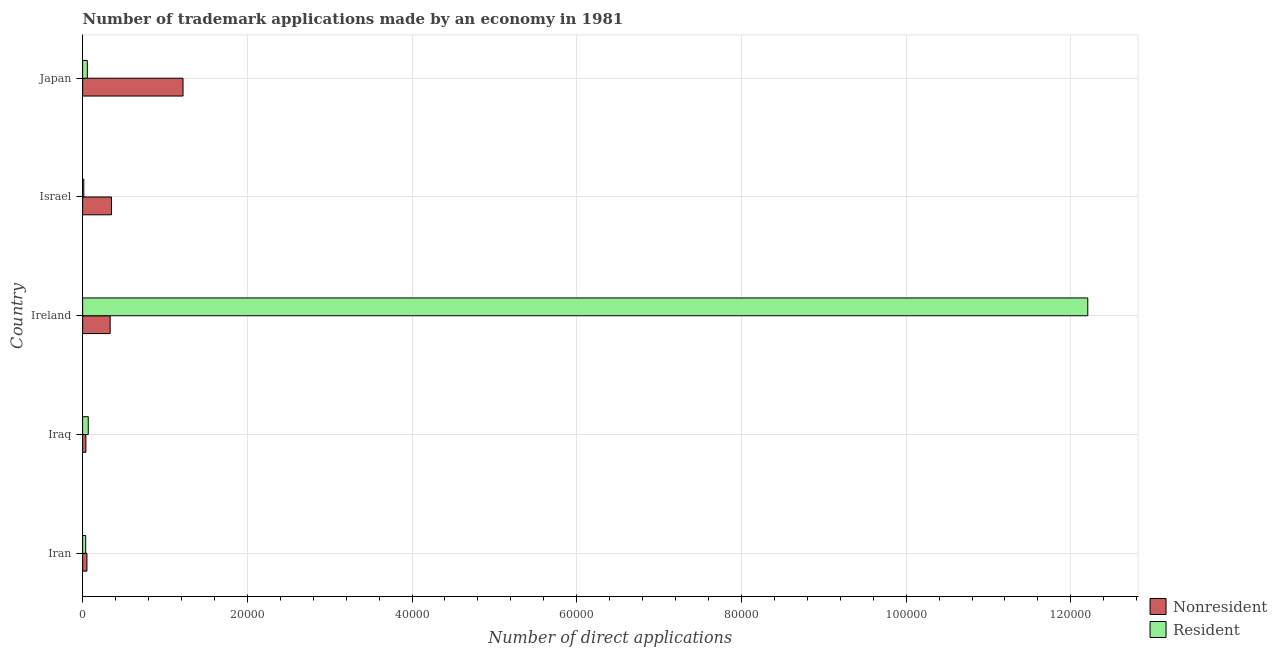What is the number of trademark applications made by residents in Japan?
Your answer should be compact. 570. Across all countries, what is the maximum number of trademark applications made by residents?
Your answer should be very brief. 1.22e+05. Across all countries, what is the minimum number of trademark applications made by residents?
Ensure brevity in your answer.  142. In which country was the number of trademark applications made by residents maximum?
Give a very brief answer. Ireland. In which country was the number of trademark applications made by non residents minimum?
Your answer should be compact. Iraq. What is the total number of trademark applications made by non residents in the graph?
Your answer should be very brief. 2.00e+04. What is the difference between the number of trademark applications made by non residents in Iraq and that in Japan?
Offer a terse response. -1.18e+04. What is the difference between the number of trademark applications made by residents in Japan and the number of trademark applications made by non residents in Israel?
Make the answer very short. -2936. What is the average number of trademark applications made by non residents per country?
Make the answer very short. 3992.2. What is the difference between the number of trademark applications made by residents and number of trademark applications made by non residents in Japan?
Make the answer very short. -1.16e+04. In how many countries, is the number of trademark applications made by residents greater than 8000 ?
Keep it short and to the point. 1. What is the ratio of the number of trademark applications made by non residents in Iran to that in Japan?
Make the answer very short. 0.04. What is the difference between the highest and the second highest number of trademark applications made by non residents?
Keep it short and to the point. 8686. What is the difference between the highest and the lowest number of trademark applications made by non residents?
Keep it short and to the point. 1.18e+04. Is the sum of the number of trademark applications made by non residents in Iran and Iraq greater than the maximum number of trademark applications made by residents across all countries?
Offer a very short reply. No. What does the 1st bar from the top in Iran represents?
Offer a very short reply. Resident. What does the 2nd bar from the bottom in Israel represents?
Your response must be concise. Resident. How many countries are there in the graph?
Your answer should be very brief. 5. Where does the legend appear in the graph?
Provide a succinct answer. Bottom right. How many legend labels are there?
Make the answer very short. 2. How are the legend labels stacked?
Provide a succinct answer. Vertical. What is the title of the graph?
Provide a succinct answer. Number of trademark applications made by an economy in 1981. Does "Merchandise exports" appear as one of the legend labels in the graph?
Offer a terse response. No. What is the label or title of the X-axis?
Your response must be concise. Number of direct applications. What is the label or title of the Y-axis?
Provide a short and direct response. Country. What is the Number of direct applications of Nonresident in Iran?
Your response must be concise. 523. What is the Number of direct applications in Resident in Iran?
Your answer should be compact. 373. What is the Number of direct applications in Nonresident in Iraq?
Your response must be concise. 397. What is the Number of direct applications in Resident in Iraq?
Give a very brief answer. 684. What is the Number of direct applications of Nonresident in Ireland?
Give a very brief answer. 3343. What is the Number of direct applications of Resident in Ireland?
Offer a very short reply. 1.22e+05. What is the Number of direct applications in Nonresident in Israel?
Keep it short and to the point. 3506. What is the Number of direct applications of Resident in Israel?
Keep it short and to the point. 142. What is the Number of direct applications of Nonresident in Japan?
Your answer should be compact. 1.22e+04. What is the Number of direct applications of Resident in Japan?
Offer a terse response. 570. Across all countries, what is the maximum Number of direct applications of Nonresident?
Offer a terse response. 1.22e+04. Across all countries, what is the maximum Number of direct applications in Resident?
Your answer should be very brief. 1.22e+05. Across all countries, what is the minimum Number of direct applications of Nonresident?
Your response must be concise. 397. Across all countries, what is the minimum Number of direct applications in Resident?
Offer a terse response. 142. What is the total Number of direct applications of Nonresident in the graph?
Your response must be concise. 2.00e+04. What is the total Number of direct applications of Resident in the graph?
Offer a very short reply. 1.24e+05. What is the difference between the Number of direct applications in Nonresident in Iran and that in Iraq?
Provide a short and direct response. 126. What is the difference between the Number of direct applications of Resident in Iran and that in Iraq?
Give a very brief answer. -311. What is the difference between the Number of direct applications in Nonresident in Iran and that in Ireland?
Give a very brief answer. -2820. What is the difference between the Number of direct applications of Resident in Iran and that in Ireland?
Give a very brief answer. -1.22e+05. What is the difference between the Number of direct applications in Nonresident in Iran and that in Israel?
Offer a terse response. -2983. What is the difference between the Number of direct applications in Resident in Iran and that in Israel?
Offer a very short reply. 231. What is the difference between the Number of direct applications of Nonresident in Iran and that in Japan?
Your response must be concise. -1.17e+04. What is the difference between the Number of direct applications of Resident in Iran and that in Japan?
Your answer should be compact. -197. What is the difference between the Number of direct applications in Nonresident in Iraq and that in Ireland?
Ensure brevity in your answer.  -2946. What is the difference between the Number of direct applications in Resident in Iraq and that in Ireland?
Your answer should be compact. -1.21e+05. What is the difference between the Number of direct applications of Nonresident in Iraq and that in Israel?
Your response must be concise. -3109. What is the difference between the Number of direct applications of Resident in Iraq and that in Israel?
Your response must be concise. 542. What is the difference between the Number of direct applications in Nonresident in Iraq and that in Japan?
Offer a very short reply. -1.18e+04. What is the difference between the Number of direct applications of Resident in Iraq and that in Japan?
Give a very brief answer. 114. What is the difference between the Number of direct applications of Nonresident in Ireland and that in Israel?
Keep it short and to the point. -163. What is the difference between the Number of direct applications of Resident in Ireland and that in Israel?
Make the answer very short. 1.22e+05. What is the difference between the Number of direct applications in Nonresident in Ireland and that in Japan?
Provide a short and direct response. -8849. What is the difference between the Number of direct applications in Resident in Ireland and that in Japan?
Ensure brevity in your answer.  1.21e+05. What is the difference between the Number of direct applications in Nonresident in Israel and that in Japan?
Your answer should be very brief. -8686. What is the difference between the Number of direct applications in Resident in Israel and that in Japan?
Make the answer very short. -428. What is the difference between the Number of direct applications in Nonresident in Iran and the Number of direct applications in Resident in Iraq?
Ensure brevity in your answer.  -161. What is the difference between the Number of direct applications in Nonresident in Iran and the Number of direct applications in Resident in Ireland?
Provide a short and direct response. -1.22e+05. What is the difference between the Number of direct applications of Nonresident in Iran and the Number of direct applications of Resident in Israel?
Provide a succinct answer. 381. What is the difference between the Number of direct applications of Nonresident in Iran and the Number of direct applications of Resident in Japan?
Make the answer very short. -47. What is the difference between the Number of direct applications of Nonresident in Iraq and the Number of direct applications of Resident in Ireland?
Make the answer very short. -1.22e+05. What is the difference between the Number of direct applications of Nonresident in Iraq and the Number of direct applications of Resident in Israel?
Give a very brief answer. 255. What is the difference between the Number of direct applications of Nonresident in Iraq and the Number of direct applications of Resident in Japan?
Ensure brevity in your answer.  -173. What is the difference between the Number of direct applications in Nonresident in Ireland and the Number of direct applications in Resident in Israel?
Make the answer very short. 3201. What is the difference between the Number of direct applications of Nonresident in Ireland and the Number of direct applications of Resident in Japan?
Provide a succinct answer. 2773. What is the difference between the Number of direct applications of Nonresident in Israel and the Number of direct applications of Resident in Japan?
Keep it short and to the point. 2936. What is the average Number of direct applications in Nonresident per country?
Make the answer very short. 3992.2. What is the average Number of direct applications of Resident per country?
Your answer should be compact. 2.48e+04. What is the difference between the Number of direct applications in Nonresident and Number of direct applications in Resident in Iran?
Provide a succinct answer. 150. What is the difference between the Number of direct applications in Nonresident and Number of direct applications in Resident in Iraq?
Provide a short and direct response. -287. What is the difference between the Number of direct applications of Nonresident and Number of direct applications of Resident in Ireland?
Offer a very short reply. -1.19e+05. What is the difference between the Number of direct applications in Nonresident and Number of direct applications in Resident in Israel?
Your answer should be very brief. 3364. What is the difference between the Number of direct applications of Nonresident and Number of direct applications of Resident in Japan?
Your answer should be compact. 1.16e+04. What is the ratio of the Number of direct applications of Nonresident in Iran to that in Iraq?
Your response must be concise. 1.32. What is the ratio of the Number of direct applications in Resident in Iran to that in Iraq?
Give a very brief answer. 0.55. What is the ratio of the Number of direct applications in Nonresident in Iran to that in Ireland?
Keep it short and to the point. 0.16. What is the ratio of the Number of direct applications in Resident in Iran to that in Ireland?
Make the answer very short. 0. What is the ratio of the Number of direct applications of Nonresident in Iran to that in Israel?
Keep it short and to the point. 0.15. What is the ratio of the Number of direct applications of Resident in Iran to that in Israel?
Give a very brief answer. 2.63. What is the ratio of the Number of direct applications of Nonresident in Iran to that in Japan?
Give a very brief answer. 0.04. What is the ratio of the Number of direct applications of Resident in Iran to that in Japan?
Provide a succinct answer. 0.65. What is the ratio of the Number of direct applications in Nonresident in Iraq to that in Ireland?
Make the answer very short. 0.12. What is the ratio of the Number of direct applications in Resident in Iraq to that in Ireland?
Provide a succinct answer. 0.01. What is the ratio of the Number of direct applications in Nonresident in Iraq to that in Israel?
Your answer should be very brief. 0.11. What is the ratio of the Number of direct applications in Resident in Iraq to that in Israel?
Your response must be concise. 4.82. What is the ratio of the Number of direct applications of Nonresident in Iraq to that in Japan?
Provide a short and direct response. 0.03. What is the ratio of the Number of direct applications of Resident in Iraq to that in Japan?
Ensure brevity in your answer.  1.2. What is the ratio of the Number of direct applications of Nonresident in Ireland to that in Israel?
Make the answer very short. 0.95. What is the ratio of the Number of direct applications of Resident in Ireland to that in Israel?
Provide a short and direct response. 859.57. What is the ratio of the Number of direct applications of Nonresident in Ireland to that in Japan?
Your answer should be very brief. 0.27. What is the ratio of the Number of direct applications in Resident in Ireland to that in Japan?
Offer a terse response. 214.14. What is the ratio of the Number of direct applications in Nonresident in Israel to that in Japan?
Provide a succinct answer. 0.29. What is the ratio of the Number of direct applications in Resident in Israel to that in Japan?
Provide a short and direct response. 0.25. What is the difference between the highest and the second highest Number of direct applications in Nonresident?
Make the answer very short. 8686. What is the difference between the highest and the second highest Number of direct applications of Resident?
Ensure brevity in your answer.  1.21e+05. What is the difference between the highest and the lowest Number of direct applications of Nonresident?
Provide a short and direct response. 1.18e+04. What is the difference between the highest and the lowest Number of direct applications in Resident?
Provide a short and direct response. 1.22e+05. 